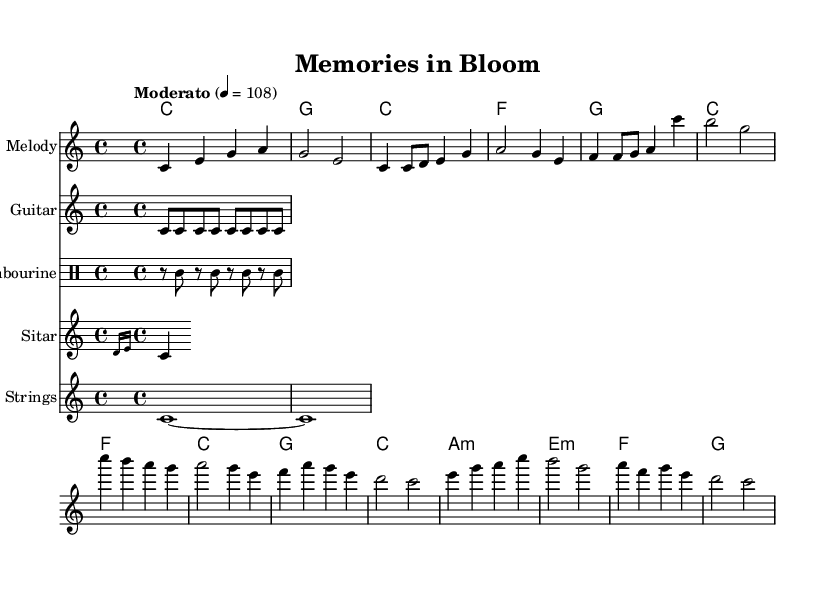What is the key signature of this music? The key signature is C major, which has no sharps or flats noted at the beginning of the score.
Answer: C major What is the time signature of this music? The time signature appears at the beginning of the score as 4/4, indicating four beats per measure.
Answer: 4/4 What is the tempo marking for this piece? The tempo is indicated within the score, reading "Moderato" with a metronome marking of 108 beats per minute.
Answer: Moderato 108 What instrument plays the sitar part? The sitar part is notated under its own staff labeled "Sitar," indicating this specific instrument plays the given notes.
Answer: Sitar How many measures are in the bridge section? The bridge consists of four measures, as counted from the measures that are clearly sectioned in the sheet music.
Answer: 4 What is the first chord in the verse? The first chord of the verse is noted in the chord names section, listing the C major chord at the beginning of the verse.
Answer: C What is the last note of the melody? The last note of the melody can be found by looking at the final measure of the melody staff, which shows a note value of C.
Answer: C 